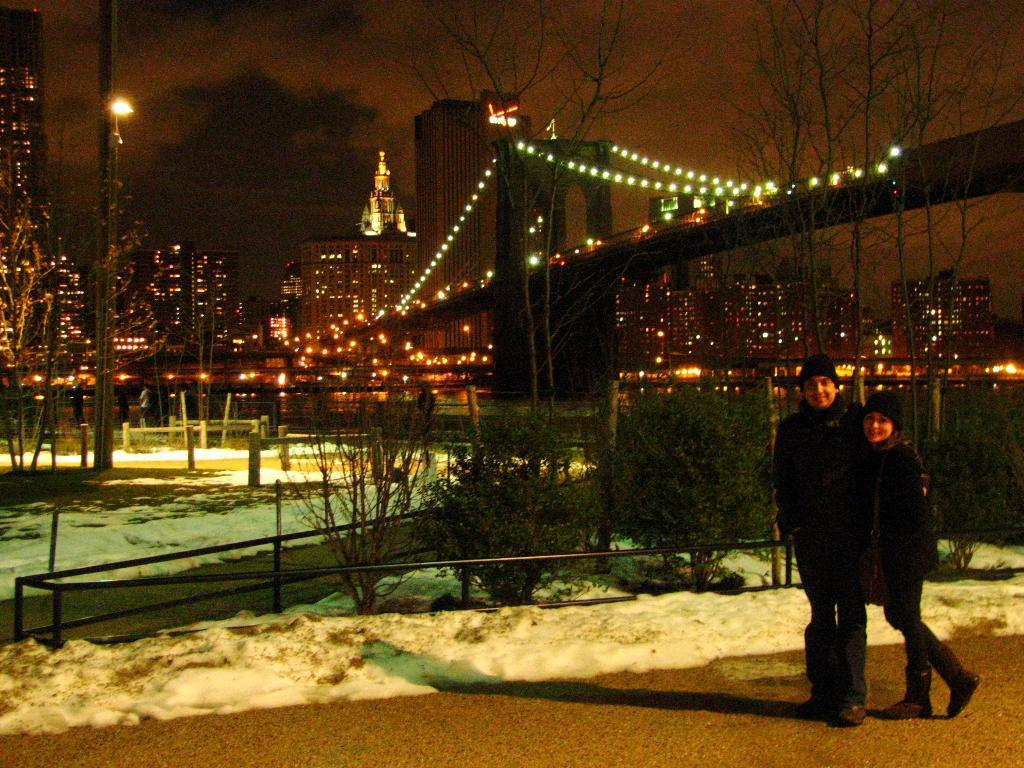How many people are in the image? There are two persons in the image. What can be seen in the background of the image? There is a group of plants, buildings, lights, and a bridge visible in the background. Can you describe the left side of the image? There is a tree and a pole with lights on the left side of the image. What type of crime is being committed in the image? There is no indication of any crime being committed in the image. 